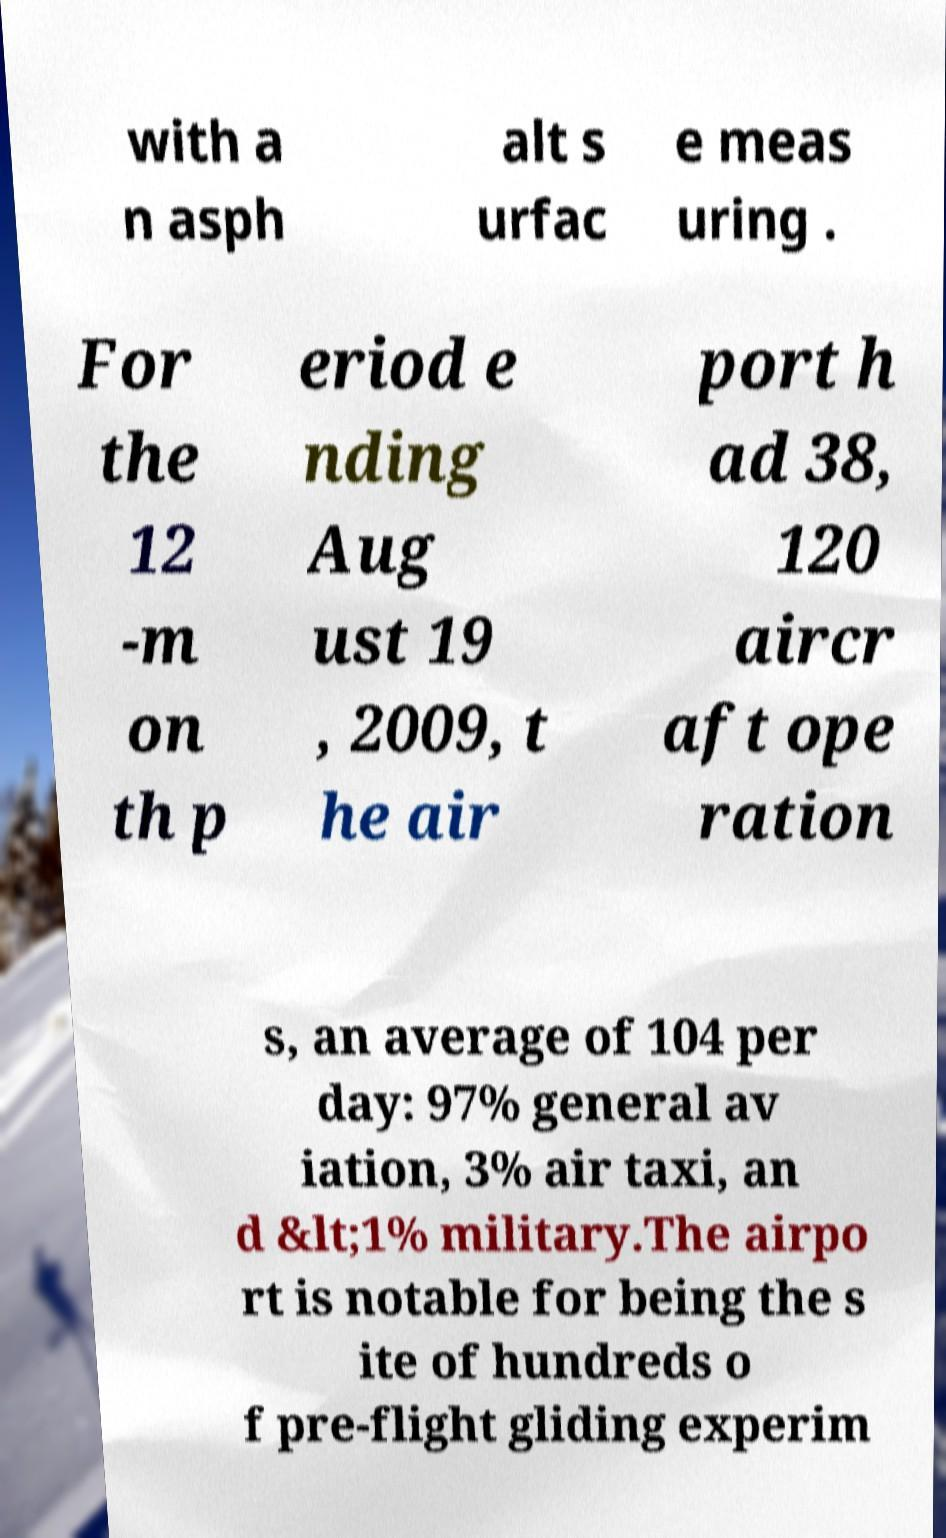Could you assist in decoding the text presented in this image and type it out clearly? with a n asph alt s urfac e meas uring . For the 12 -m on th p eriod e nding Aug ust 19 , 2009, t he air port h ad 38, 120 aircr aft ope ration s, an average of 104 per day: 97% general av iation, 3% air taxi, an d &lt;1% military.The airpo rt is notable for being the s ite of hundreds o f pre-flight gliding experim 